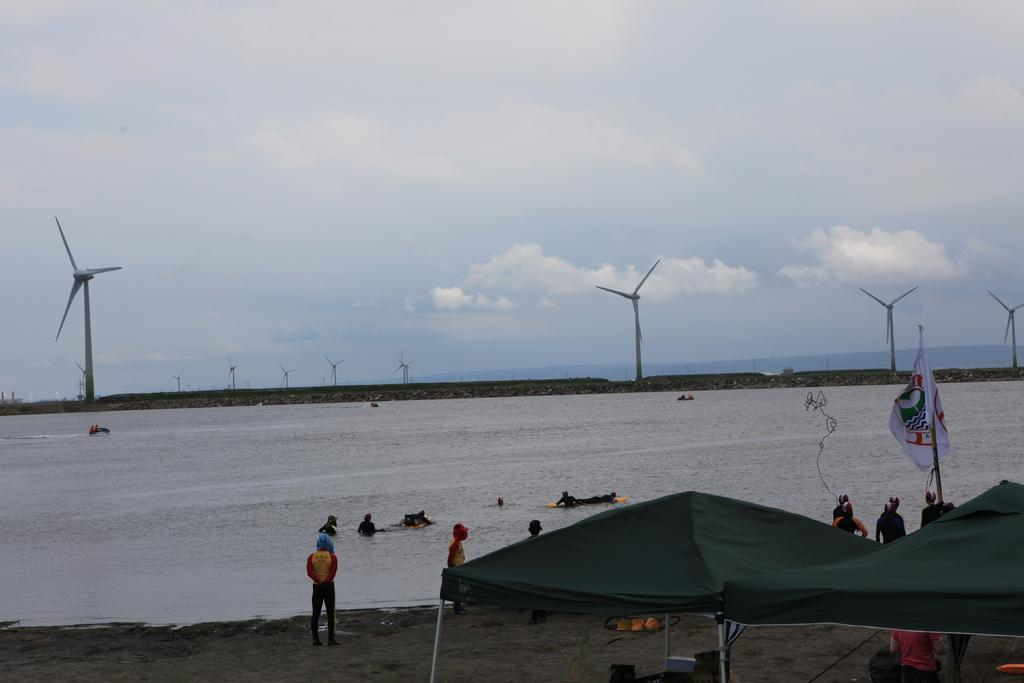What are the persons in the image doing? The persons in the image are standing on the land. What structures can be seen behind the persons? The persons are in front of tents. What natural feature is visible in the background? There is a lake in the background. What type of structures are near the lake? Windmills are present near the lake. What is visible above the land and lake? The sky is visible in the image. What can be observed in the sky? Clouds are present in the sky. How many eggs are visible in the image? There are no eggs present in the image. What type of cemetery can be seen in the image? There is no cemetery present in the image. 